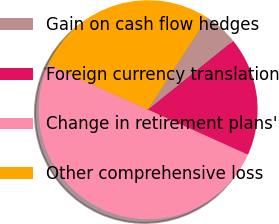Convert chart to OTSL. <chart><loc_0><loc_0><loc_500><loc_500><pie_chart><fcel>Gain on cash flow hedges<fcel>Foreign currency translation<fcel>Change in retirement plans'<fcel>Other comprehensive loss<nl><fcel>5.07%<fcel>17.55%<fcel>50.03%<fcel>27.35%<nl></chart> 